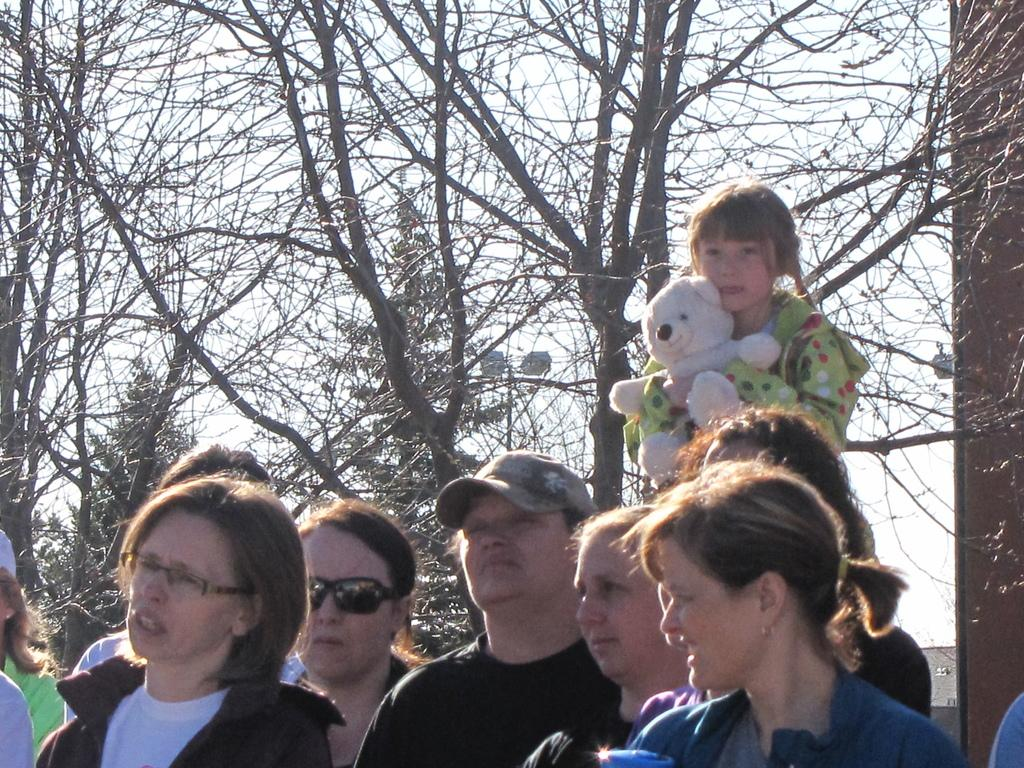How many people are in the group visible in the image? There is a group of people in the image, but the exact number cannot be determined from the provided facts. What type of toy can be seen in the image? There is a teddy bear toy in the image. What type of vegetation is present in the image? There are trees in the image. What is visible at the top of the image? The sky is visible at the top of the image. What type of fang can be seen in the image? There is no fang present in the image. Can you tell me how many fish are swimming in the sea in the image? There is no sea or fish visible in the image. 